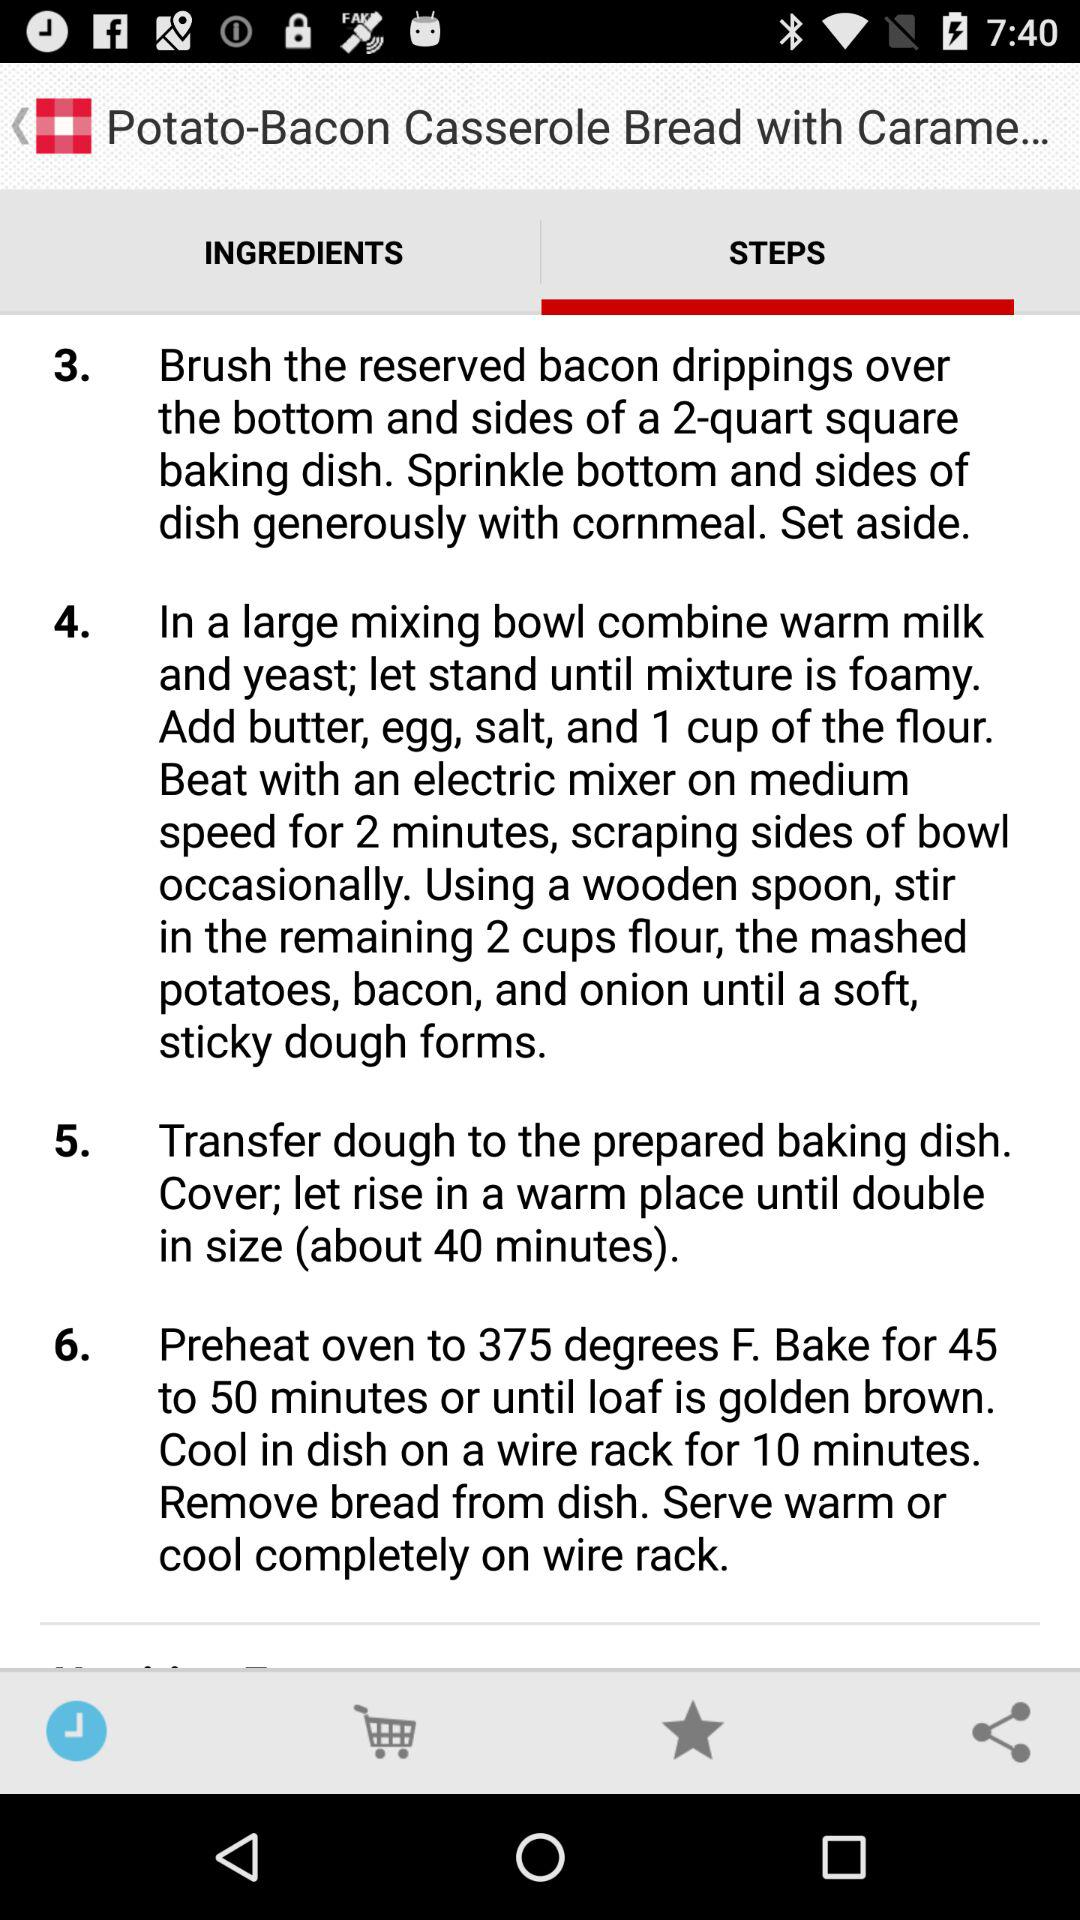Which tab is selected? The selected tabs are "STEPS" and "Recent". 